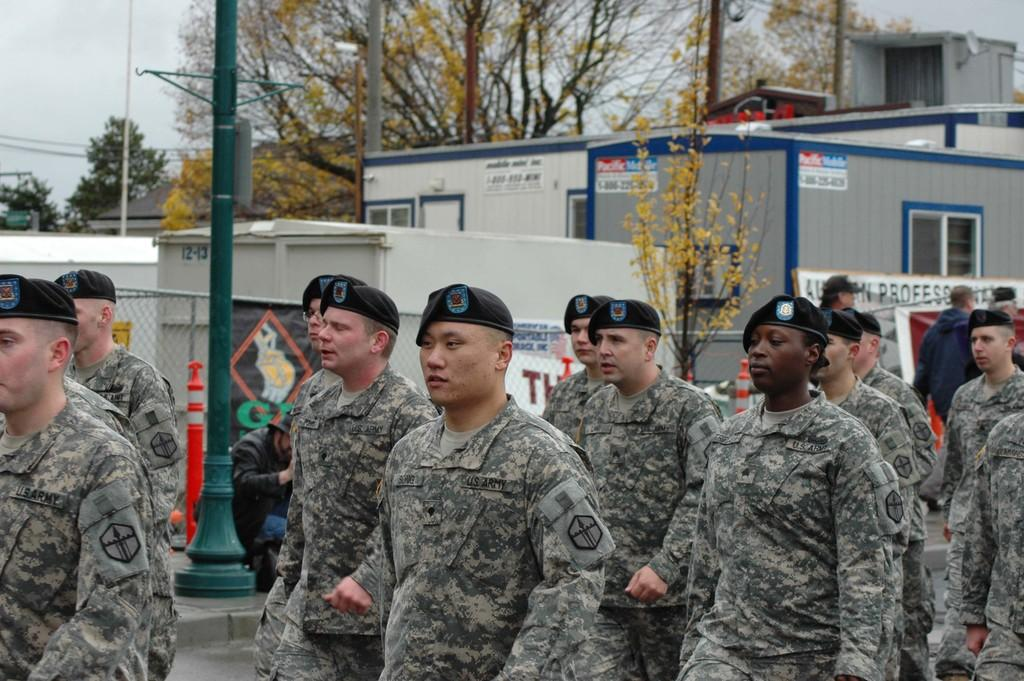What are the people in the image doing? The people in the image are walking on the road in the foreground. What objects can be seen in the image besides people? There are poles, trees, buildings, and banners visible in the image. What is visible in the background of the image? The sky is visible in the image. What type of fowl can be seen making a decision in the image? There are no fowl present in the image, and therefore no such decision-making can be observed. 